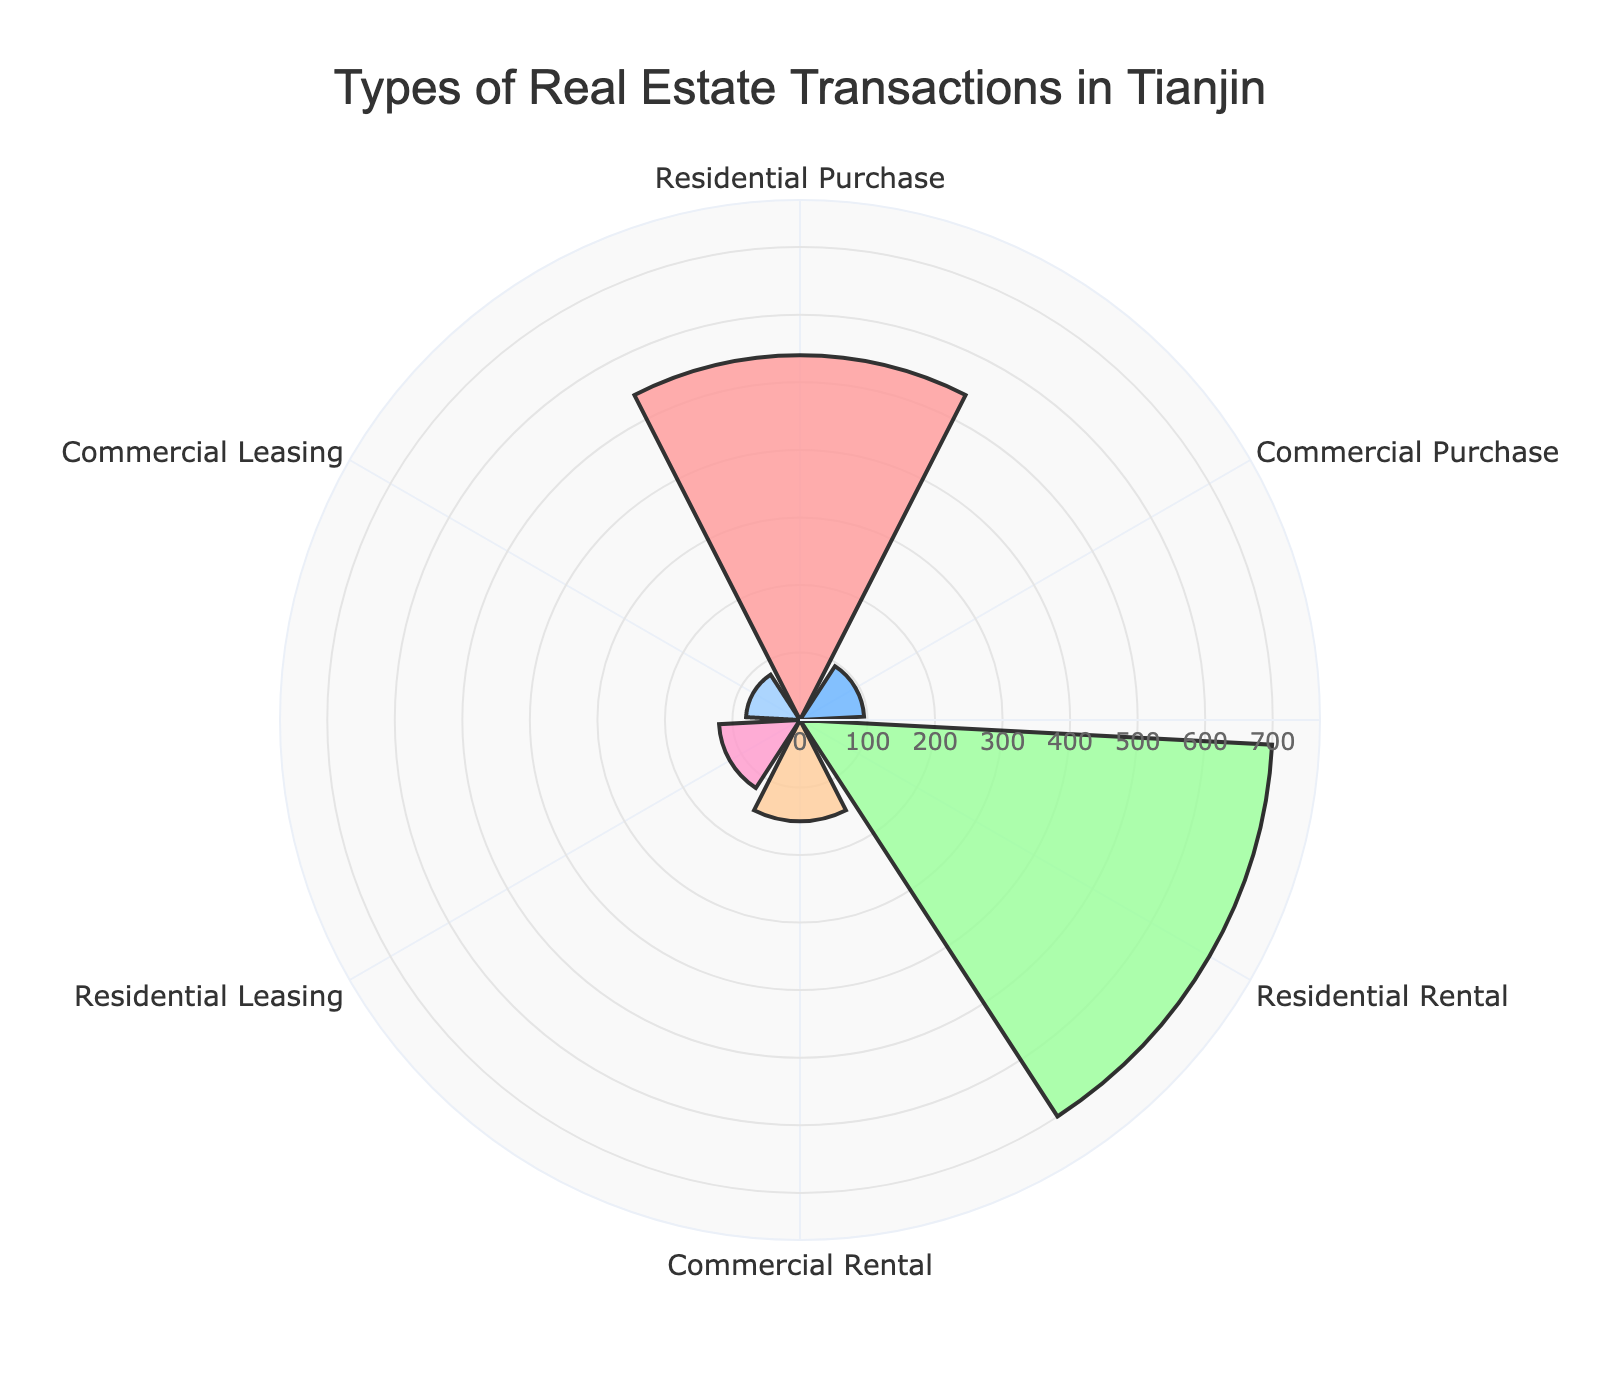What's the title of the chart? The title of the chart is usually prominently displayed at the top and provides a concise summary of what the chart is about. In this case, the title is "Types of Real Estate Transactions in Tianjin" as it pertains to the various real estate transactions in Tianjin.
Answer: Types of Real Estate Transactions in Tianjin What is the highest number of transactions for a single type? To determine the highest number of transactions, look at the lengths of the bars extending from the center outward. The longest bar corresponds to the largest value. Here, the "Residential Rental" section has the highest value, totaling 700 transactions.
Answer: 700 How many transaction types are displayed in the chart? Count the number of unique segments or bars presented in the polar area chart. Each segment represents a different transaction type. There are six different segments in the chart, each representing a unique transaction type.
Answer: 6 Which transaction type has fewer transactions: Commercial Purchase or Commercial Leasing? Compare the lengths of the bars for "Commercial Purchase" and "Commercial Leasing." The bar for "Commercial Leasing" is shorter than that for "Commercial Purchase," indicating fewer transactions.
Answer: Commercial Leasing What's the total number of transactions for purchases (Residential plus Commercial)? Sum the number of transactions for both types of purchases: Residential Purchase (540) and Commercial Purchase (95). Adding these values gives 540 + 95 = 635.
Answer: 635 Are there more transactions for rentals or leasing? Add the transactions for rental types (Residential Rental and Commercial Rental) and compare them to the sum for leasing types (Residential Leasing and Commercial Leasing). Rentals: 700 + 150 = 850, Leasing: 120 + 80 = 200. There are more transactions for rentals.
Answer: Rentals What percentage of total transactions does Residential Purchase represent? First, calculate the total number of transactions across all types. Then find the percentage by dividing the Residential Purchase transactions by the total and multiplying by 100. Total transactions = 540 + 95 + 700 + 150 + 120 + 80 = 1685. Percentage = (540 / 1685) * 100 ≈ 32.05%.
Answer: 32.05% Which transaction type has the second lowest number? Identify the bars with numbers close to the lowest value and compare them. The smallest bar is "Commercial Leasing" (80), and the next smallest is "Commercial Purchase" (95). Thus, the second lowest is Commercial Purchase.
Answer: Commercial Purchase Which is larger, Residential Leasing or Residential Purchase? Compare the lengths of the bars for "Residential Leasing" and "Residential Purchase." The bar for "Residential Purchase" is longer, indicating a higher value.
Answer: Residential Purchase 